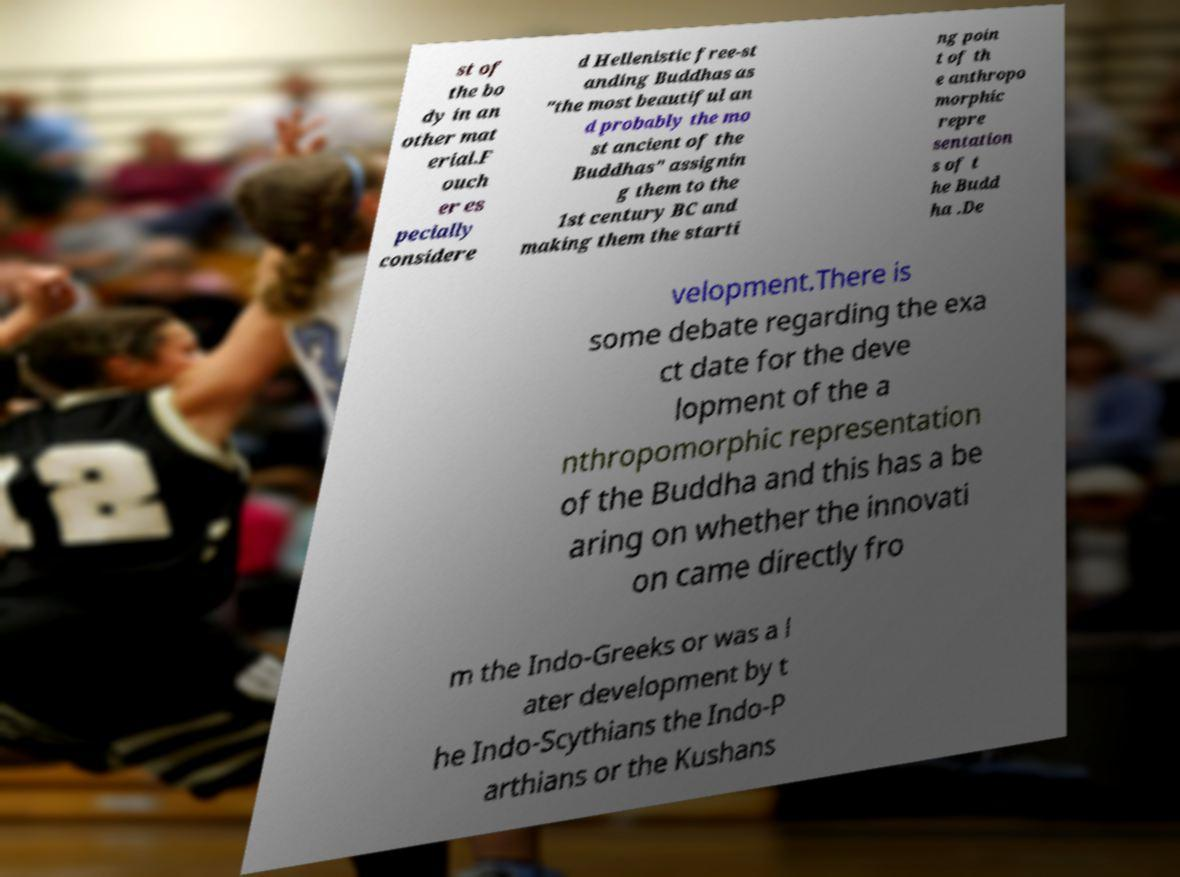For documentation purposes, I need the text within this image transcribed. Could you provide that? st of the bo dy in an other mat erial.F ouch er es pecially considere d Hellenistic free-st anding Buddhas as "the most beautiful an d probably the mo st ancient of the Buddhas" assignin g them to the 1st century BC and making them the starti ng poin t of th e anthropo morphic repre sentation s of t he Budd ha .De velopment.There is some debate regarding the exa ct date for the deve lopment of the a nthropomorphic representation of the Buddha and this has a be aring on whether the innovati on came directly fro m the Indo-Greeks or was a l ater development by t he Indo-Scythians the Indo-P arthians or the Kushans 